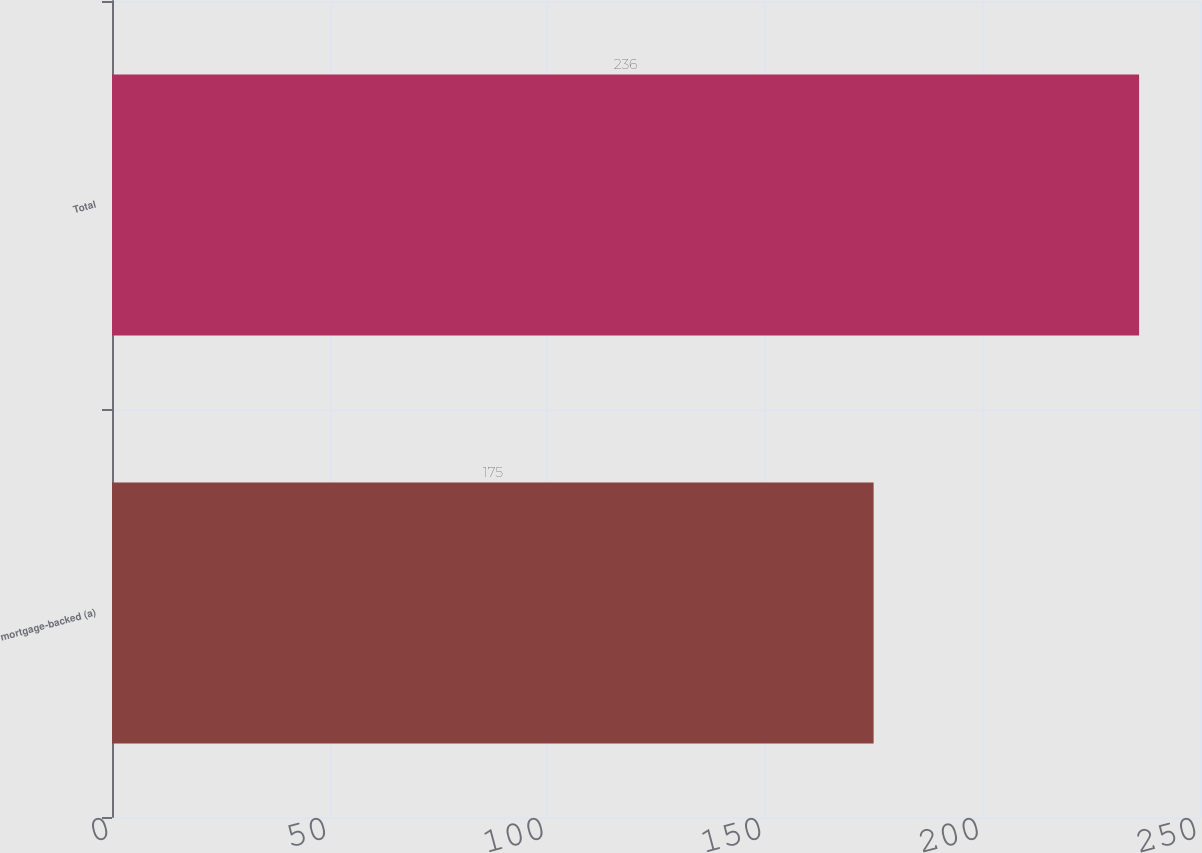Convert chart. <chart><loc_0><loc_0><loc_500><loc_500><bar_chart><fcel>mortgage-backed (a)<fcel>Total<nl><fcel>175<fcel>236<nl></chart> 